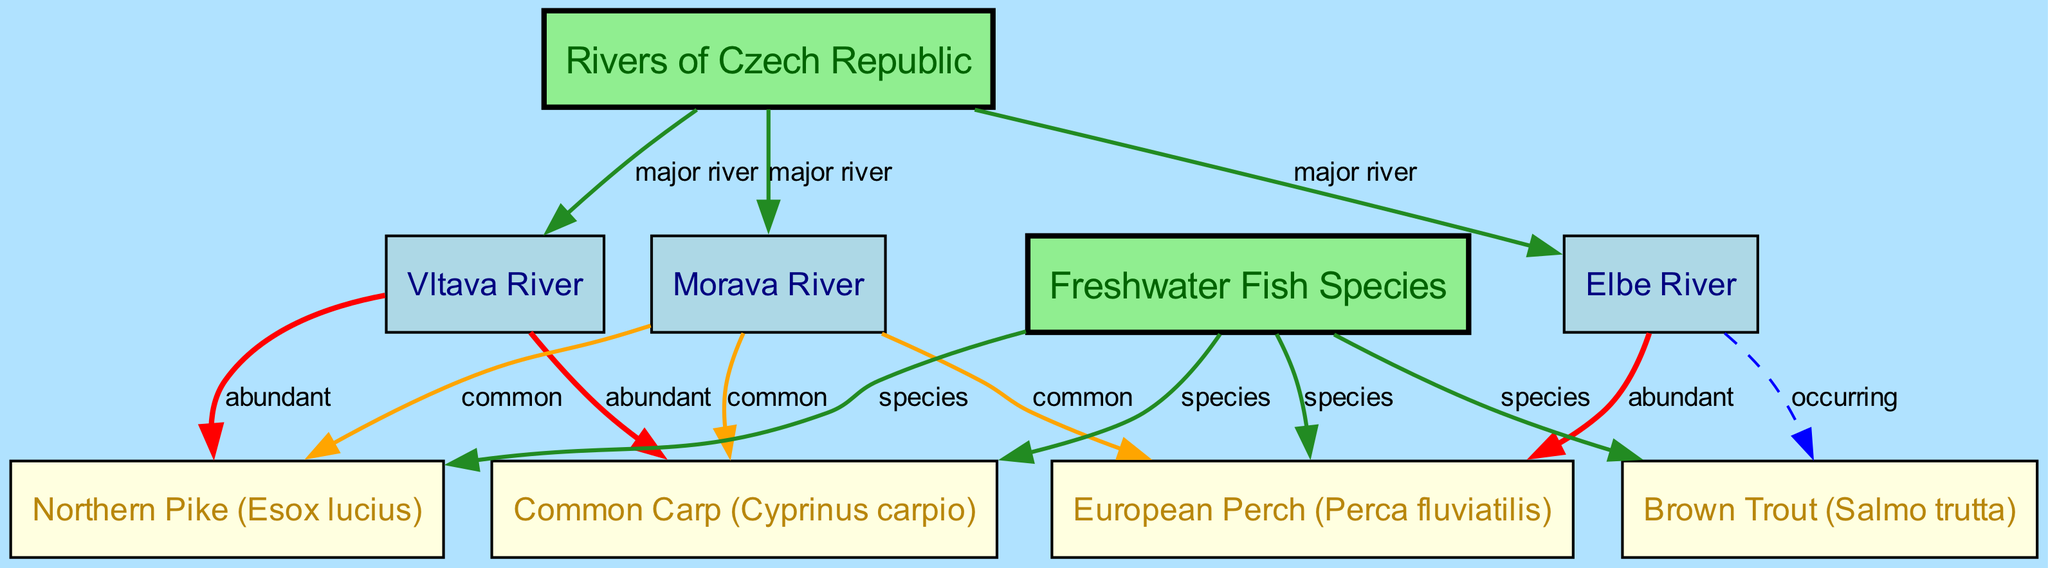What are the major rivers depicted in the diagram? The diagram shows three major rivers in the Czech Republic: Vltava River, Elbe River, and Morava River. These nodes are directly connected to the "Rivers" node, indicating their classification as major rivers.
Answer: Vltava, Elbe, Morava Which fish species is marked as abundant in the Vltava River? The Vltava River node has edges labeled "abundant" connecting it to two fish species: Common Carp and Northern Pike. This indicates that these two species are found commonly in that river.
Answer: Common Carp, Northern Pike How many fish species are represented in the diagram? There are four fish species nodes in the diagram, which include Common Carp, Northern Pike, Brown Trout, and European Perch. Each of these species connects to the "FishSpecies" node.
Answer: Four What is the relationship between the Elbe River and Brown Trout? In the diagram, the Elbe River has an edge labeled "occurring" that connects it to the Brown Trout species, indicating that this species can be found in the Elbe River but may not be abundant.
Answer: Occurring Which fish species are common in the Morava River? The Morava River has edges labeled "common" that connect it to three species: Common Carp, Northern Pike, and European Perch. This indicates that these fish species are typically found in the Morava River.
Answer: Common Carp, Northern Pike, European Perch Is the Northern Pike classified as abundant in any river? The diagram shows that the Northern Pike has edges leading from both the Vltava River and the Morava River labeled "abundant" and "common," which indicates its prevalence in these rivers.
Answer: Yes Which river is associated with the European Perch? The European Perch is indicated to be abundant in the Elbe River through a direct connection labeled "abundant," which suggests its significant presence there as compared to the other rivers.
Answer: Elbe River How many edges connect fish species to rivers in the diagram? By counting all the connections (edges) between the fish species and rivers, we see that Common Carp connects to two rivers, Northern Pike connects to two rivers, Perch connects to one river, and Trout connects to one river. This results in a total of six edges.
Answer: Six 